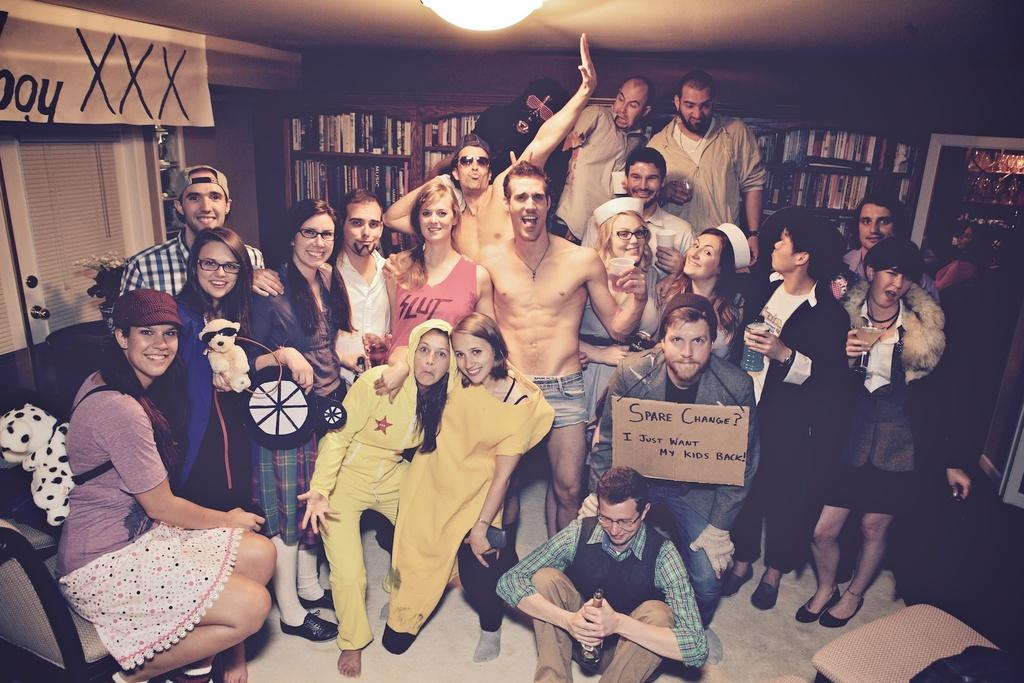How many people are present in the room in the image? There are many people in the room in the image. What can be seen in the background of the image? There is a bookshelf in the background. Where is the light located in the image? The light is on the top. What is the mood of the people in the image? All the people in the image are smiling. Is there anyone in the image wearing a card? Yes, one person is wearing a card. What type of structure can be seen in the sky in the image? There is no structure visible in the sky in the image, as the image is set indoors and does not show the sky. 